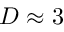Convert formula to latex. <formula><loc_0><loc_0><loc_500><loc_500>D \approx 3</formula> 